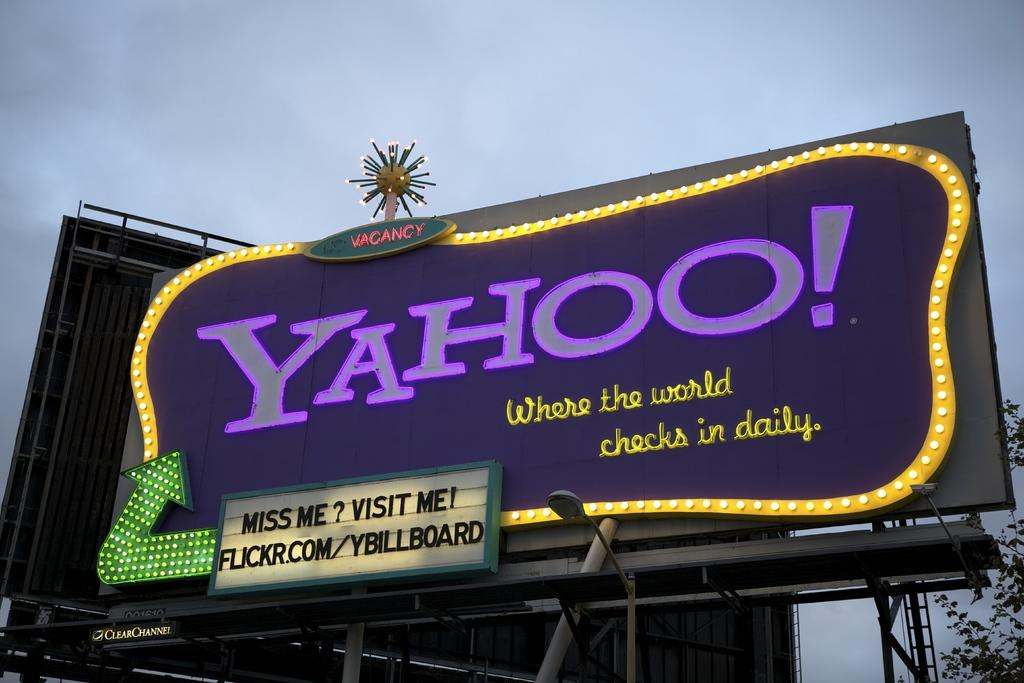Provide a one-sentence caption for the provided image. A billboard for Yahoo shows a website address on it. 